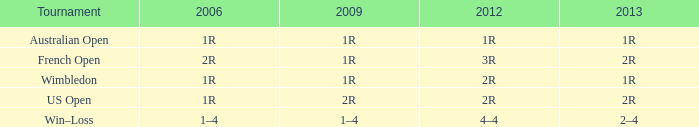What displays for 2013 when the 2012 is 2r, and a 2009 is 2r? 2R. 